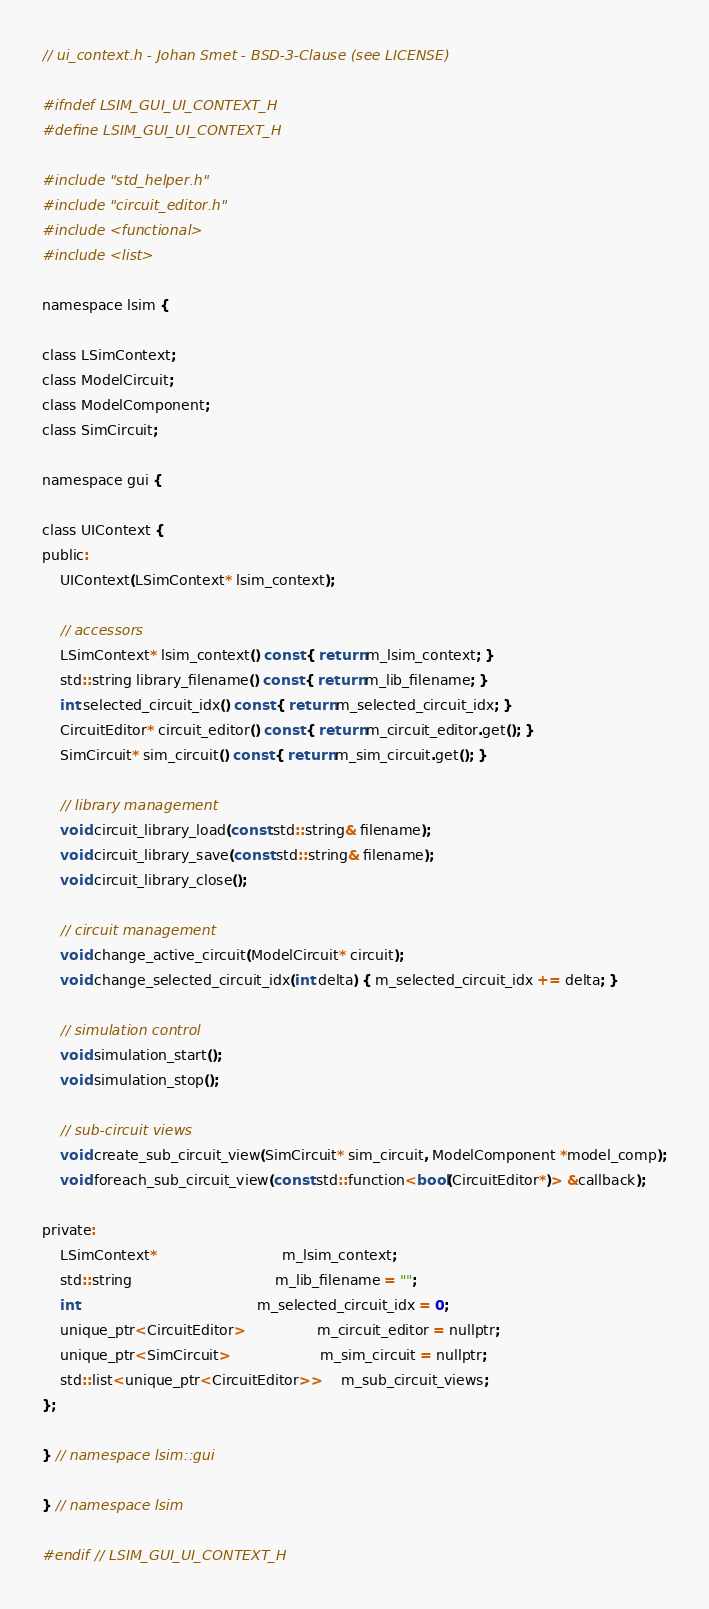Convert code to text. <code><loc_0><loc_0><loc_500><loc_500><_C_>// ui_context.h - Johan Smet - BSD-3-Clause (see LICENSE)

#ifndef LSIM_GUI_UI_CONTEXT_H
#define LSIM_GUI_UI_CONTEXT_H

#include "std_helper.h"
#include "circuit_editor.h"
#include <functional>
#include <list>

namespace lsim {

class LSimContext;
class ModelCircuit;
class ModelComponent;
class SimCircuit;

namespace gui {

class UIContext {
public:
	UIContext(LSimContext* lsim_context);

	// accessors
	LSimContext* lsim_context() const { return m_lsim_context; }
	std::string library_filename() const { return m_lib_filename; }
	int selected_circuit_idx() const { return m_selected_circuit_idx; }
	CircuitEditor* circuit_editor() const { return m_circuit_editor.get(); }
	SimCircuit* sim_circuit() const { return m_sim_circuit.get(); }

	// library management
	void circuit_library_load(const std::string& filename);
	void circuit_library_save(const std::string& filename);
	void circuit_library_close();

	// circuit management
	void change_active_circuit(ModelCircuit* circuit);
	void change_selected_circuit_idx(int delta) { m_selected_circuit_idx += delta; }

	// simulation control
	void simulation_start();
	void simulation_stop();

	// sub-circuit views
	void create_sub_circuit_view(SimCircuit* sim_circuit, ModelComponent *model_comp);
	void foreach_sub_circuit_view(const std::function<bool(CircuitEditor*)> &callback);

private:
	LSimContext*							m_lsim_context;
	std::string								m_lib_filename = "";
	int										m_selected_circuit_idx = 0;
	unique_ptr<CircuitEditor>				m_circuit_editor = nullptr;
	unique_ptr<SimCircuit>					m_sim_circuit = nullptr;
	std::list<unique_ptr<CircuitEditor>>	m_sub_circuit_views;
};

} // namespace lsim::gui

} // namespace lsim

#endif // LSIM_GUI_UI_CONTEXT_H
</code> 